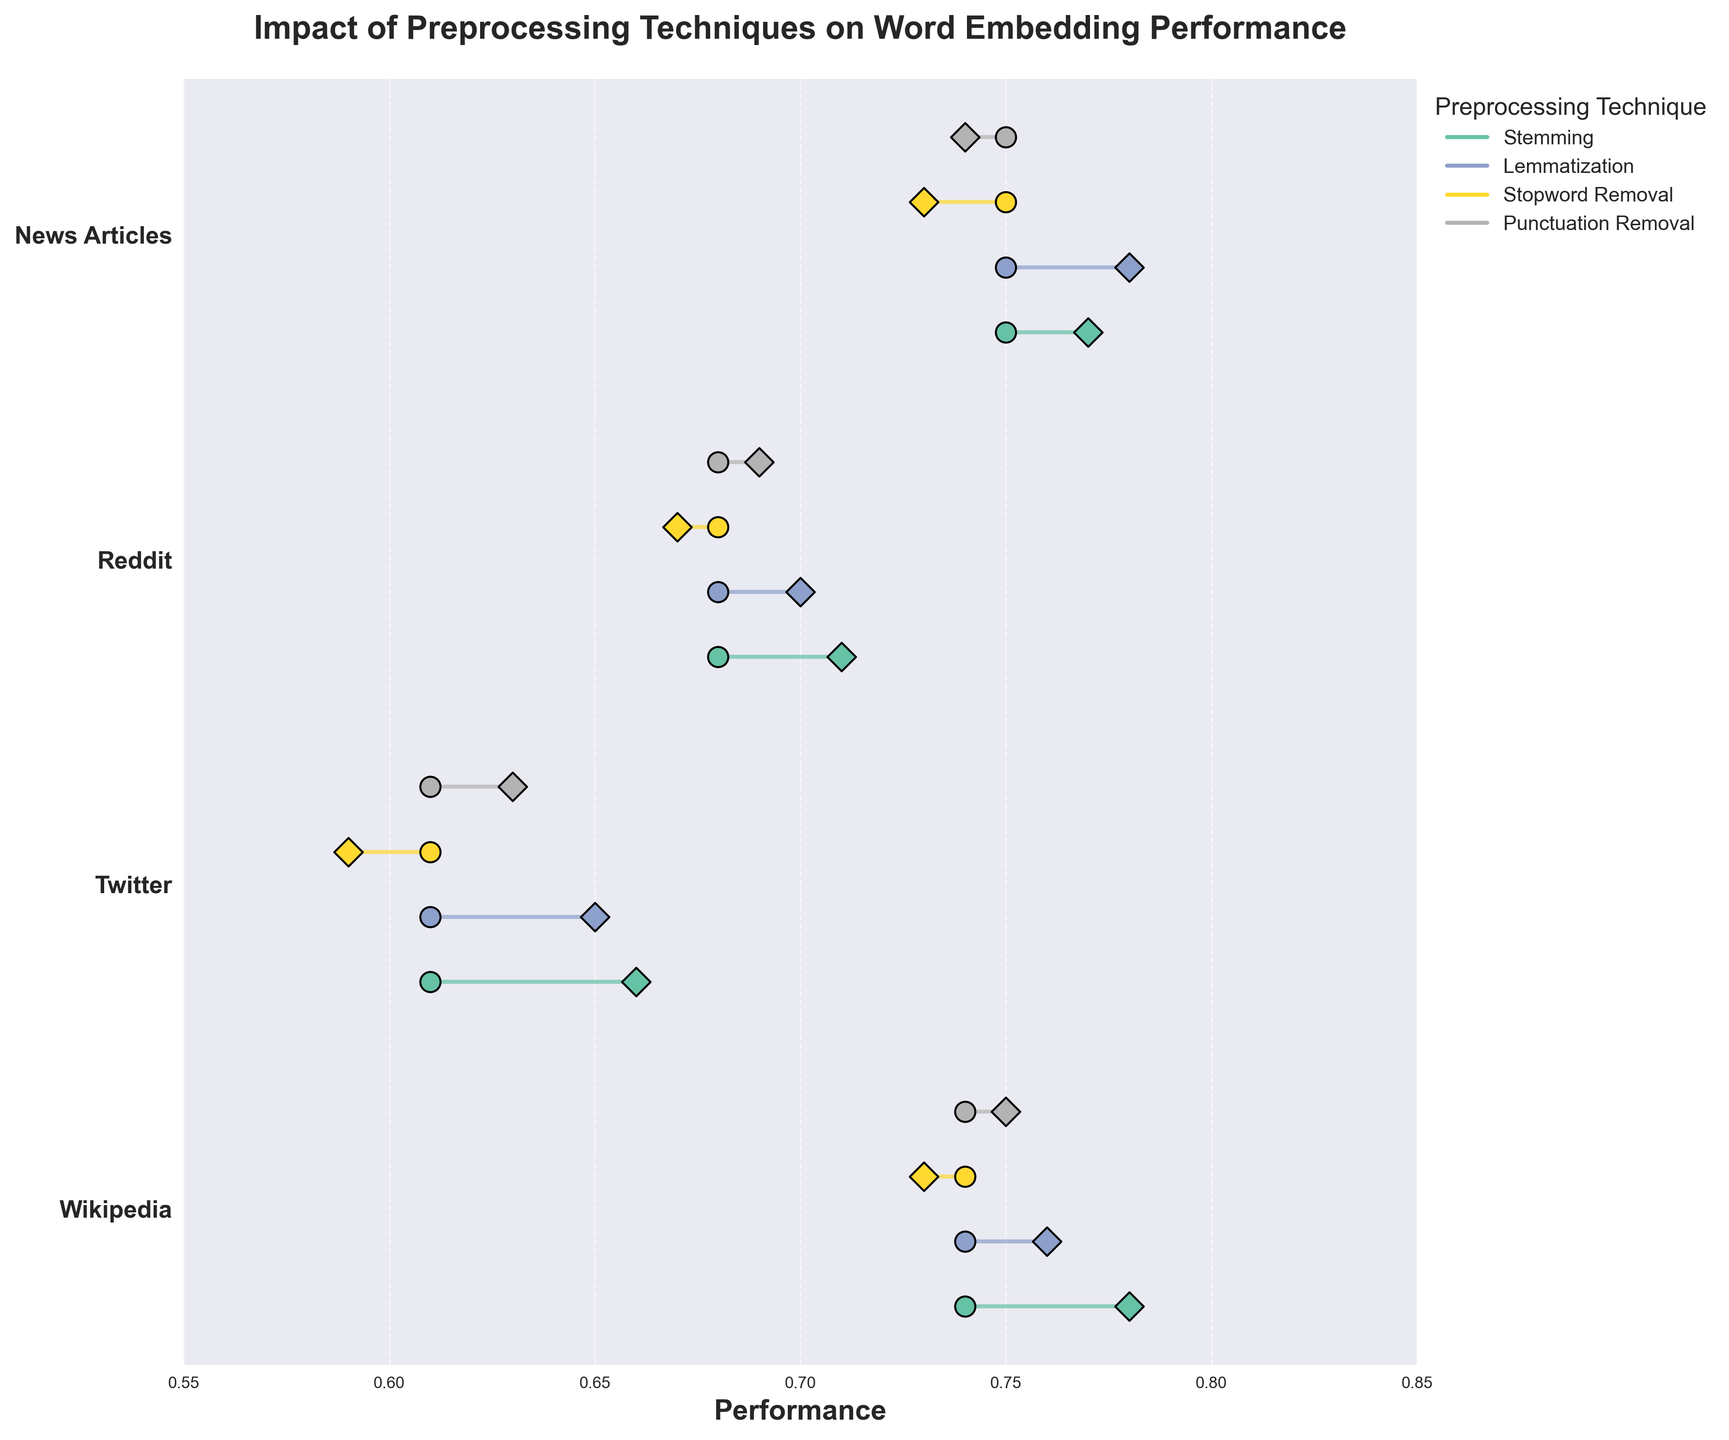Which preprocessing technique has the highest performance improvement for the Wikipedia corpus? To determine this, look at the difference between performance before and after for each preprocessing technique applied to the Wikipedia corpus. Stemming shows an improvement from 0.74 to 0.78, lemmatization from 0.74 to 0.76, stopword removal shows a decline, and punctuation removal from 0.74 to 0.75. Therefore, stemming has the highest improvement.
Answer: Stemming Comparing stopword removal across all corpora, which corpus experiences the least performance change? Examine the impact of stopword removal on each corpus. Wikipedia goes from 0.74 to 0.73 (a decrease of 0.01), Twitter from 0.61 to 0.59 (a decrease of 0.02), Reddit from 0.68 to 0.67 (a decrease of 0.01), and News Articles from 0.75 to 0.73 (a decrease of 0.02). Both Wikipedia and Reddit experience the least change of 0.01.
Answer: Wikipedia and Reddit Which word embedding model is used with the News Articles corpus? Look at the title and note the section labeled "News Articles." The model associated with this corpus uses the GloVe word embedding model.
Answer: GloVe What is the overall observed trend for the model performance after applying stemming to different corpora? Stemming improves Wikipedia from 0.74 to 0.78, Twitter from 0.61 to 0.66, Reddit from 0.68 to 0.71, and News Articles from 0.75 to 0.77. Therefore, stemming shows a performance improvement across all corpora.
Answer: Improvement across all corpora Which preprocessing technique shows a decline in performance for the highest number of corpora? Review each preprocessing technique and note the number of declines: Stemming (0 declines), Lemmatization (0 declines), Stopword Removal (decline in Wikipedia and Twitter, no change in Reddit and News Articles), Punctuation Removal (0 declines). Stopword removal shows the most declines.
Answer: Stopword Removal Among the preprocessing techniques applied to the Reddit corpus, which one leads to the highest performance after preprocessing? Examine the performance after preprocessing for each technique: stemming (0.71), lemmatization (0.70), stopword removal (0.67), and punctuation removal (0.69). Stemming results in the highest performance.
Answer: Stemming In the Twitter corpus, which preprocessing technique results in the highest final performance, and what is that value? Look at the Twitter corpus and check the "Performance After" values: stemming (0.66), lemmatization (0.65), stopword removal (0.59), punctuation removal (0.63). Stemming results in the highest final performance of 0.66.
Answer: Stemming, 0.66 Which corpus has the highest baseline (performance before preprocessing) performance? Compare the "Performance Before" values for each corpus: Wikipedia (0.74), Twitter (0.61), Reddit (0.68), and News Articles (0.75). News Articles has the highest baseline performance.
Answer: News Articles 